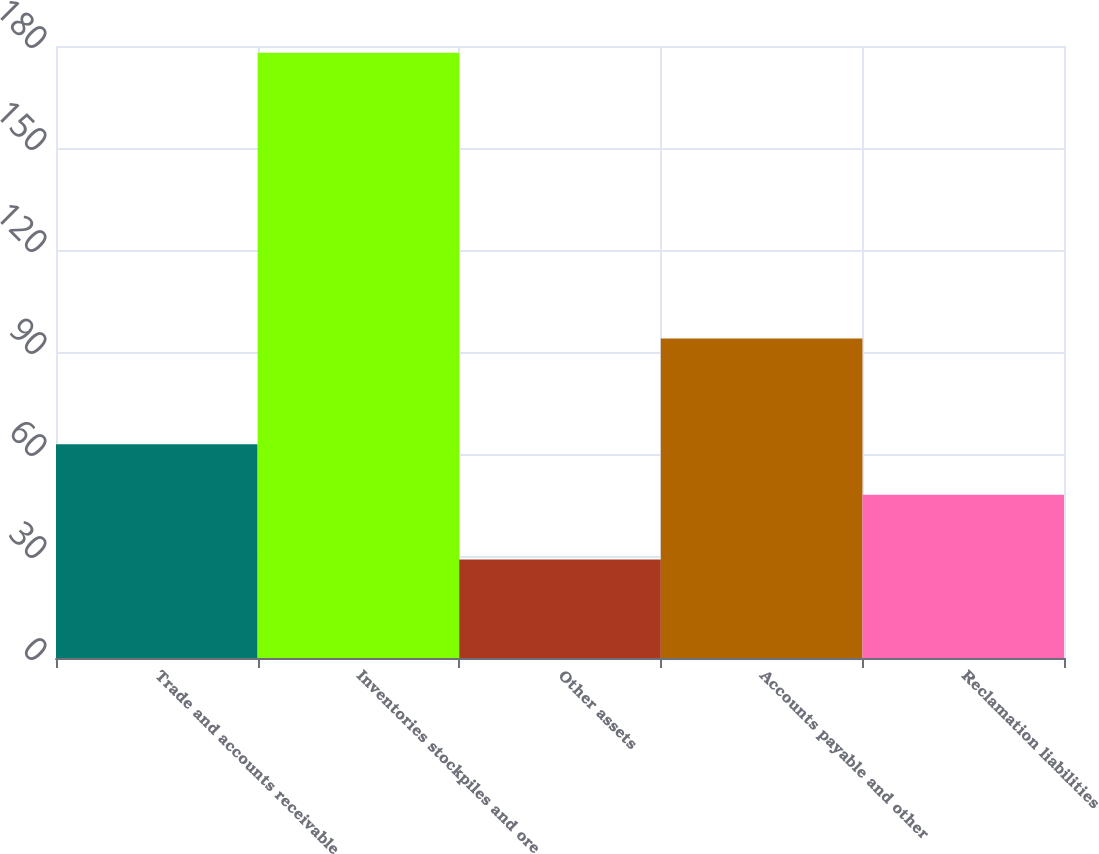<chart> <loc_0><loc_0><loc_500><loc_500><bar_chart><fcel>Trade and accounts receivable<fcel>Inventories stockpiles and ore<fcel>Other assets<fcel>Accounts payable and other<fcel>Reclamation liabilities<nl><fcel>62.9<fcel>178<fcel>29<fcel>94<fcel>48<nl></chart> 